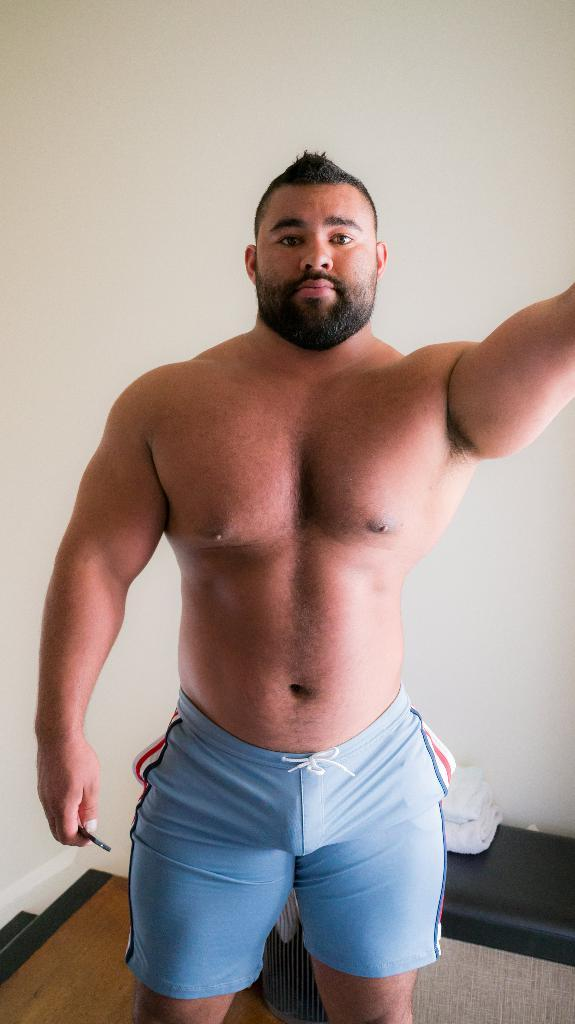Who or what is present in the image? There is a person in the image. What can be seen behind the person? There is a wall in the background of the image. What type of flooring is visible at the bottom of the image? There is wooden flooring at the bottom of the image. What type of light bulb is hanging from the ceiling in the image? There is no light bulb or ceiling visible in the image. 